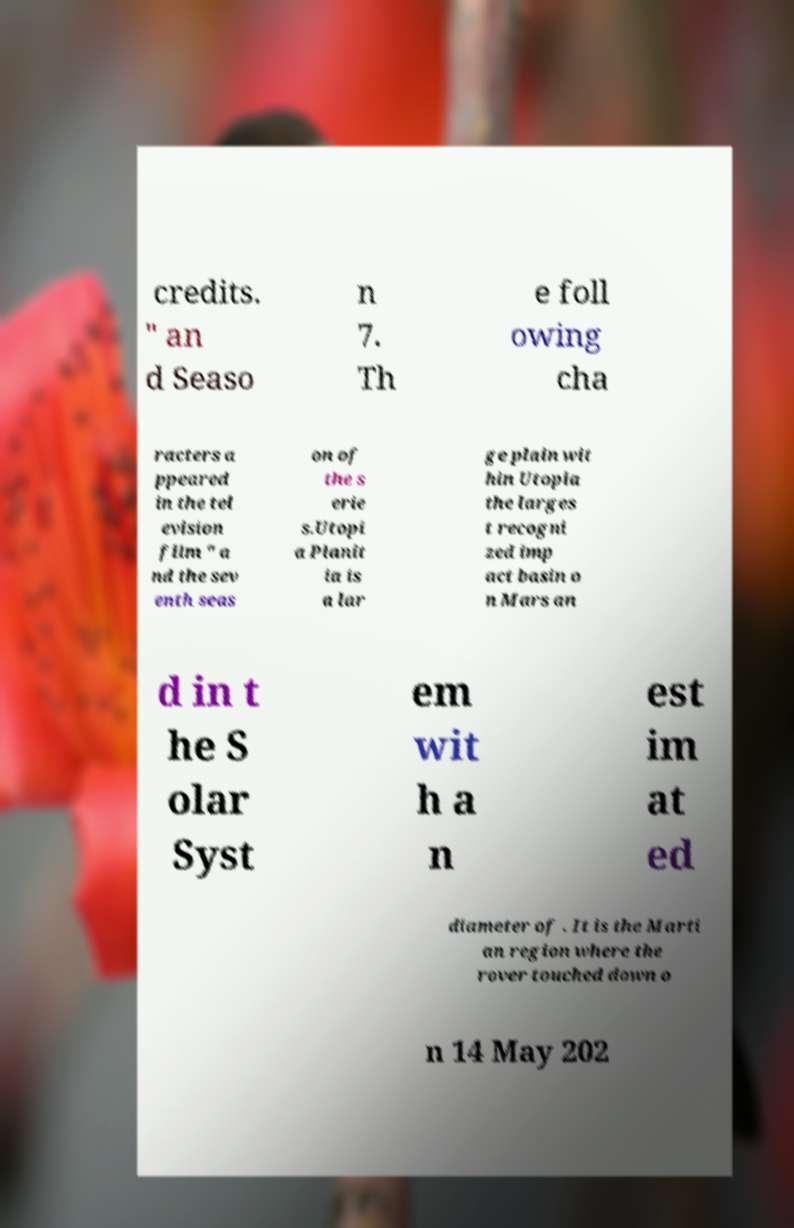For documentation purposes, I need the text within this image transcribed. Could you provide that? credits. " an d Seaso n 7. Th e foll owing cha racters a ppeared in the tel evision film " a nd the sev enth seas on of the s erie s.Utopi a Planit ia is a lar ge plain wit hin Utopia the larges t recogni zed imp act basin o n Mars an d in t he S olar Syst em wit h a n est im at ed diameter of . It is the Marti an region where the rover touched down o n 14 May 202 